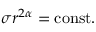Convert formula to latex. <formula><loc_0><loc_0><loc_500><loc_500>\sigma r ^ { 2 \alpha } = c o n s t .</formula> 